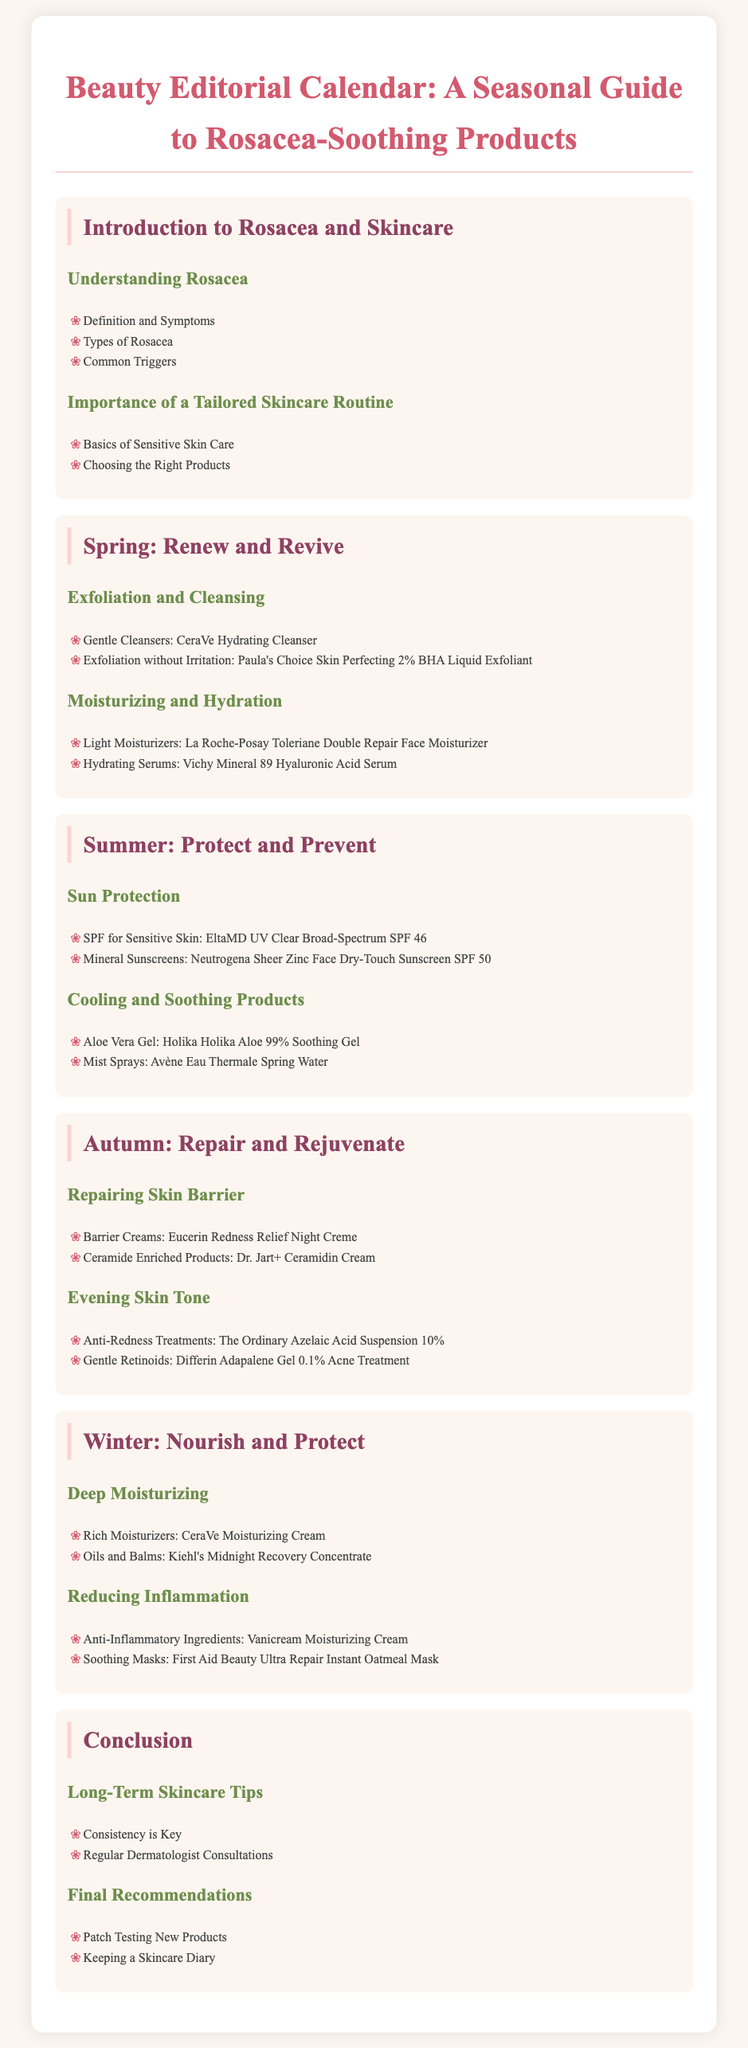What are common triggers for rosacea? The document lists common triggers that can aggravate rosacea, including exposure to sunlight, stress, and certain foods.
Answer: Not specified What is a gentle cleanser recommended for spring? The document specifies a gentle cleanser that is suitable for spring skincare routines, which is CeraVe Hydrating Cleanser.
Answer: CeraVe Hydrating Cleanser Which product is suggested for sun protection in summer? The document mentions a recommended product for sun protection specifically for sensitive skin, which is EltaMD UV Clear Broad-Spectrum SPF 46.
Answer: EltaMD UV Clear Broad-Spectrum SPF 46 What moisture-rich cream is advised for winter? The document recommends a rich moisturizer for winter, which is CeraVe Moisturizing Cream.
Answer: CeraVe Moisturizing Cream What main goals does the autumn section focus on? The document highlights the focus on repairing the skin barrier and evening skin tone during autumn.
Answer: Repairing skin barrier, evening skin tone What key factor in skincare is emphasized in the conclusion? The document stresses the importance of a key factor for long-term skincare practices, which is consistency.
Answer: Consistency Which product contains anti-inflammatory ingredients for winter? The document suggests a product that contains anti-inflammatory ingredients during winter, namely Vanicream Moisturizing Cream.
Answer: Vanicream Moisturizing Cream What is the main topic of the introduction section? The document introduces the basic concepts related to rosacea and skincare.
Answer: Understanding rosacea What should be done before trying new products? The document advises patch testing new products to prevent adverse reactions.
Answer: Patch testing 